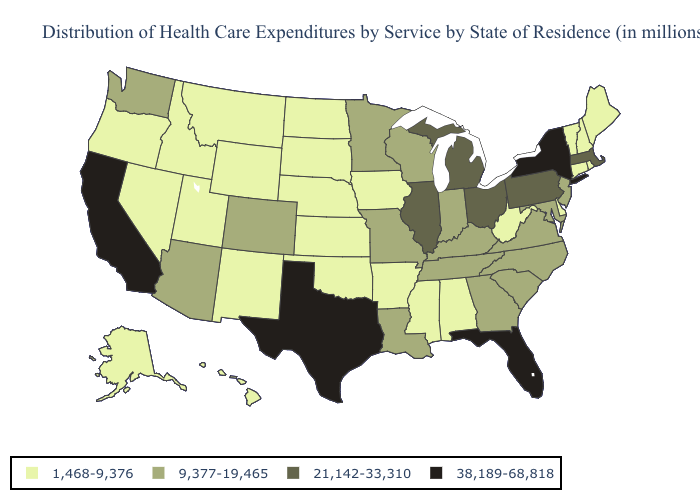What is the lowest value in states that border Pennsylvania?
Keep it brief. 1,468-9,376. Which states have the lowest value in the USA?
Be succinct. Alabama, Alaska, Arkansas, Connecticut, Delaware, Hawaii, Idaho, Iowa, Kansas, Maine, Mississippi, Montana, Nebraska, Nevada, New Hampshire, New Mexico, North Dakota, Oklahoma, Oregon, Rhode Island, South Dakota, Utah, Vermont, West Virginia, Wyoming. Name the states that have a value in the range 38,189-68,818?
Concise answer only. California, Florida, New York, Texas. Among the states that border Pennsylvania , which have the highest value?
Concise answer only. New York. Does Arkansas have the lowest value in the USA?
Concise answer only. Yes. What is the value of Wyoming?
Give a very brief answer. 1,468-9,376. How many symbols are there in the legend?
Write a very short answer. 4. Which states have the lowest value in the MidWest?
Keep it brief. Iowa, Kansas, Nebraska, North Dakota, South Dakota. What is the value of Wyoming?
Answer briefly. 1,468-9,376. Does Louisiana have the same value as Kentucky?
Concise answer only. Yes. What is the value of Idaho?
Concise answer only. 1,468-9,376. Which states have the lowest value in the USA?
Concise answer only. Alabama, Alaska, Arkansas, Connecticut, Delaware, Hawaii, Idaho, Iowa, Kansas, Maine, Mississippi, Montana, Nebraska, Nevada, New Hampshire, New Mexico, North Dakota, Oklahoma, Oregon, Rhode Island, South Dakota, Utah, Vermont, West Virginia, Wyoming. What is the highest value in the Northeast ?
Keep it brief. 38,189-68,818. Among the states that border Texas , which have the lowest value?
Give a very brief answer. Arkansas, New Mexico, Oklahoma. Does Arizona have the lowest value in the West?
Answer briefly. No. 